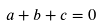Convert formula to latex. <formula><loc_0><loc_0><loc_500><loc_500>a + b + c = 0</formula> 